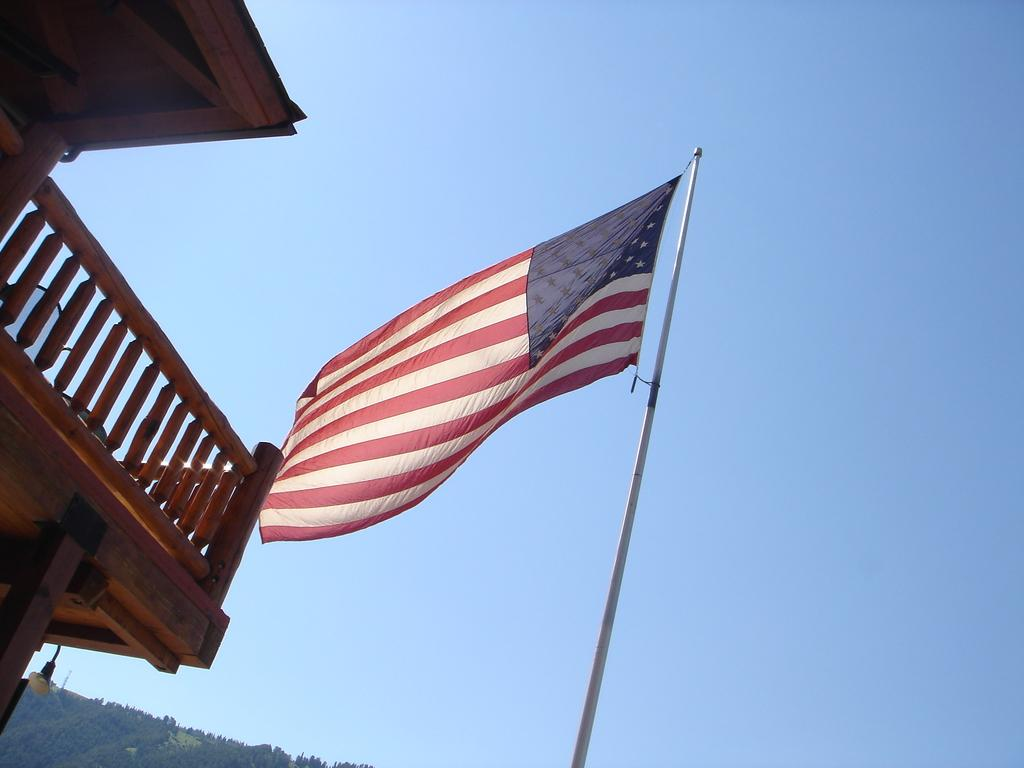What is the main subject in the middle of the image? A: There is a flag in the middle of the image. What structure can be seen on the left side of the image? There is a building on the left side of the image. What can be seen in the background of the image? The sky is visible in the background of the image. What type of vegetation is present in the bottom left-hand corner of the image? There are many trees in the bottom left-hand corner of the image. What is the tax rate for the attraction depicted in the image? There is no attraction present in the image, so it is not possible to determine the tax rate. 